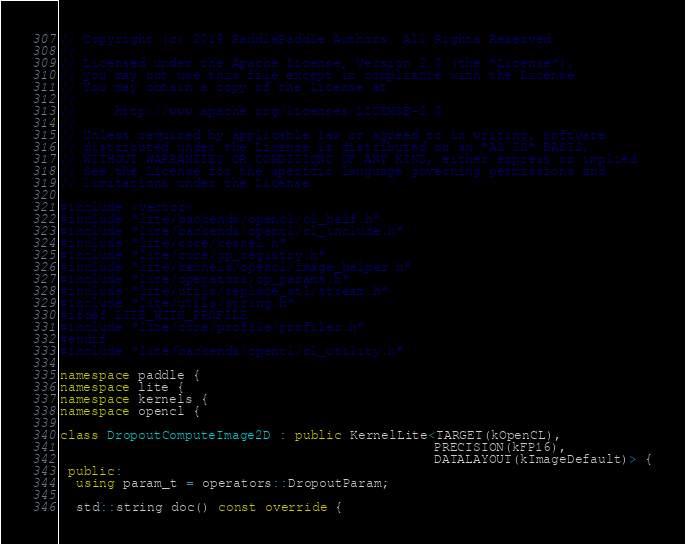<code> <loc_0><loc_0><loc_500><loc_500><_C++_>// Copyright (c) 2019 PaddlePaddle Authors. All Rights Reserved.
//
// Licensed under the Apache License, Version 2.0 (the "License");
// you may not use this file except in compliance with the License.
// You may obtain a copy of the License at
//
//     http://www.apache.org/licenses/LICENSE-2.0
//
// Unless required by applicable law or agreed to in writing, software
// distributed under the License is distributed on an "AS IS" BASIS,
// WITHOUT WARRANTIES OR CONDITIONS OF ANY KIND, either express or implied.
// See the License for the specific language governing permissions and
// limitations under the License.

#include <vector>
#include "lite/backends/opencl/cl_half.h"
#include "lite/backends/opencl/cl_include.h"
#include "lite/core/kernel.h"
#include "lite/core/op_registry.h"
#include "lite/kernels/opencl/image_helper.h"
#include "lite/operators/op_params.h"
#include "lite/utils/replace_stl/stream.h"
#include "lite/utils/string.h"
#ifdef LITE_WITH_PROFILE
#include "lite/core/profile/profiler.h"
#endif
#include "lite/backends/opencl/cl_utility.h"

namespace paddle {
namespace lite {
namespace kernels {
namespace opencl {

class DropoutComputeImage2D : public KernelLite<TARGET(kOpenCL),
                                                PRECISION(kFP16),
                                                DATALAYOUT(kImageDefault)> {
 public:
  using param_t = operators::DropoutParam;

  std::string doc() const override {</code> 